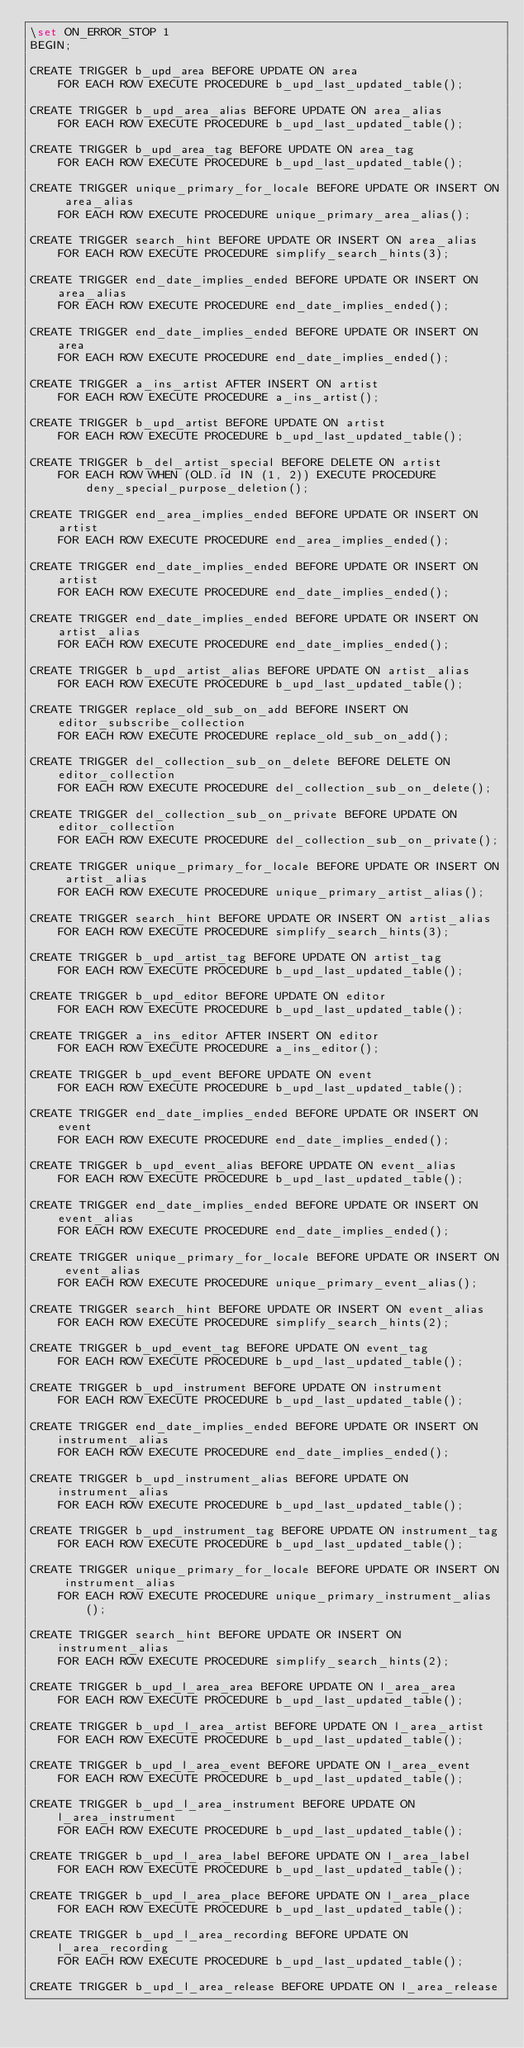<code> <loc_0><loc_0><loc_500><loc_500><_SQL_>\set ON_ERROR_STOP 1
BEGIN;

CREATE TRIGGER b_upd_area BEFORE UPDATE ON area
    FOR EACH ROW EXECUTE PROCEDURE b_upd_last_updated_table();

CREATE TRIGGER b_upd_area_alias BEFORE UPDATE ON area_alias
    FOR EACH ROW EXECUTE PROCEDURE b_upd_last_updated_table();

CREATE TRIGGER b_upd_area_tag BEFORE UPDATE ON area_tag
    FOR EACH ROW EXECUTE PROCEDURE b_upd_last_updated_table();

CREATE TRIGGER unique_primary_for_locale BEFORE UPDATE OR INSERT ON area_alias
    FOR EACH ROW EXECUTE PROCEDURE unique_primary_area_alias();

CREATE TRIGGER search_hint BEFORE UPDATE OR INSERT ON area_alias
    FOR EACH ROW EXECUTE PROCEDURE simplify_search_hints(3);

CREATE TRIGGER end_date_implies_ended BEFORE UPDATE OR INSERT ON area_alias
    FOR EACH ROW EXECUTE PROCEDURE end_date_implies_ended();

CREATE TRIGGER end_date_implies_ended BEFORE UPDATE OR INSERT ON area
    FOR EACH ROW EXECUTE PROCEDURE end_date_implies_ended();

CREATE TRIGGER a_ins_artist AFTER INSERT ON artist
    FOR EACH ROW EXECUTE PROCEDURE a_ins_artist();

CREATE TRIGGER b_upd_artist BEFORE UPDATE ON artist
    FOR EACH ROW EXECUTE PROCEDURE b_upd_last_updated_table();

CREATE TRIGGER b_del_artist_special BEFORE DELETE ON artist
    FOR EACH ROW WHEN (OLD.id IN (1, 2)) EXECUTE PROCEDURE deny_special_purpose_deletion();

CREATE TRIGGER end_area_implies_ended BEFORE UPDATE OR INSERT ON artist
    FOR EACH ROW EXECUTE PROCEDURE end_area_implies_ended();

CREATE TRIGGER end_date_implies_ended BEFORE UPDATE OR INSERT ON artist
    FOR EACH ROW EXECUTE PROCEDURE end_date_implies_ended();

CREATE TRIGGER end_date_implies_ended BEFORE UPDATE OR INSERT ON artist_alias
    FOR EACH ROW EXECUTE PROCEDURE end_date_implies_ended();

CREATE TRIGGER b_upd_artist_alias BEFORE UPDATE ON artist_alias
    FOR EACH ROW EXECUTE PROCEDURE b_upd_last_updated_table();

CREATE TRIGGER replace_old_sub_on_add BEFORE INSERT ON editor_subscribe_collection
    FOR EACH ROW EXECUTE PROCEDURE replace_old_sub_on_add();

CREATE TRIGGER del_collection_sub_on_delete BEFORE DELETE ON editor_collection
    FOR EACH ROW EXECUTE PROCEDURE del_collection_sub_on_delete();

CREATE TRIGGER del_collection_sub_on_private BEFORE UPDATE ON editor_collection
    FOR EACH ROW EXECUTE PROCEDURE del_collection_sub_on_private();

CREATE TRIGGER unique_primary_for_locale BEFORE UPDATE OR INSERT ON artist_alias
    FOR EACH ROW EXECUTE PROCEDURE unique_primary_artist_alias();

CREATE TRIGGER search_hint BEFORE UPDATE OR INSERT ON artist_alias
    FOR EACH ROW EXECUTE PROCEDURE simplify_search_hints(3);

CREATE TRIGGER b_upd_artist_tag BEFORE UPDATE ON artist_tag
    FOR EACH ROW EXECUTE PROCEDURE b_upd_last_updated_table();

CREATE TRIGGER b_upd_editor BEFORE UPDATE ON editor
    FOR EACH ROW EXECUTE PROCEDURE b_upd_last_updated_table();

CREATE TRIGGER a_ins_editor AFTER INSERT ON editor
    FOR EACH ROW EXECUTE PROCEDURE a_ins_editor();

CREATE TRIGGER b_upd_event BEFORE UPDATE ON event
    FOR EACH ROW EXECUTE PROCEDURE b_upd_last_updated_table();

CREATE TRIGGER end_date_implies_ended BEFORE UPDATE OR INSERT ON event
    FOR EACH ROW EXECUTE PROCEDURE end_date_implies_ended();

CREATE TRIGGER b_upd_event_alias BEFORE UPDATE ON event_alias
    FOR EACH ROW EXECUTE PROCEDURE b_upd_last_updated_table();

CREATE TRIGGER end_date_implies_ended BEFORE UPDATE OR INSERT ON event_alias
    FOR EACH ROW EXECUTE PROCEDURE end_date_implies_ended();

CREATE TRIGGER unique_primary_for_locale BEFORE UPDATE OR INSERT ON event_alias
    FOR EACH ROW EXECUTE PROCEDURE unique_primary_event_alias();

CREATE TRIGGER search_hint BEFORE UPDATE OR INSERT ON event_alias
    FOR EACH ROW EXECUTE PROCEDURE simplify_search_hints(2);

CREATE TRIGGER b_upd_event_tag BEFORE UPDATE ON event_tag
    FOR EACH ROW EXECUTE PROCEDURE b_upd_last_updated_table();

CREATE TRIGGER b_upd_instrument BEFORE UPDATE ON instrument
    FOR EACH ROW EXECUTE PROCEDURE b_upd_last_updated_table();

CREATE TRIGGER end_date_implies_ended BEFORE UPDATE OR INSERT ON instrument_alias
    FOR EACH ROW EXECUTE PROCEDURE end_date_implies_ended();

CREATE TRIGGER b_upd_instrument_alias BEFORE UPDATE ON instrument_alias
    FOR EACH ROW EXECUTE PROCEDURE b_upd_last_updated_table();

CREATE TRIGGER b_upd_instrument_tag BEFORE UPDATE ON instrument_tag
    FOR EACH ROW EXECUTE PROCEDURE b_upd_last_updated_table();

CREATE TRIGGER unique_primary_for_locale BEFORE UPDATE OR INSERT ON instrument_alias
    FOR EACH ROW EXECUTE PROCEDURE unique_primary_instrument_alias();

CREATE TRIGGER search_hint BEFORE UPDATE OR INSERT ON instrument_alias
    FOR EACH ROW EXECUTE PROCEDURE simplify_search_hints(2);

CREATE TRIGGER b_upd_l_area_area BEFORE UPDATE ON l_area_area
    FOR EACH ROW EXECUTE PROCEDURE b_upd_last_updated_table();

CREATE TRIGGER b_upd_l_area_artist BEFORE UPDATE ON l_area_artist
    FOR EACH ROW EXECUTE PROCEDURE b_upd_last_updated_table();

CREATE TRIGGER b_upd_l_area_event BEFORE UPDATE ON l_area_event
    FOR EACH ROW EXECUTE PROCEDURE b_upd_last_updated_table();

CREATE TRIGGER b_upd_l_area_instrument BEFORE UPDATE ON l_area_instrument
    FOR EACH ROW EXECUTE PROCEDURE b_upd_last_updated_table();

CREATE TRIGGER b_upd_l_area_label BEFORE UPDATE ON l_area_label
    FOR EACH ROW EXECUTE PROCEDURE b_upd_last_updated_table();

CREATE TRIGGER b_upd_l_area_place BEFORE UPDATE ON l_area_place
    FOR EACH ROW EXECUTE PROCEDURE b_upd_last_updated_table();

CREATE TRIGGER b_upd_l_area_recording BEFORE UPDATE ON l_area_recording
    FOR EACH ROW EXECUTE PROCEDURE b_upd_last_updated_table();

CREATE TRIGGER b_upd_l_area_release BEFORE UPDATE ON l_area_release</code> 